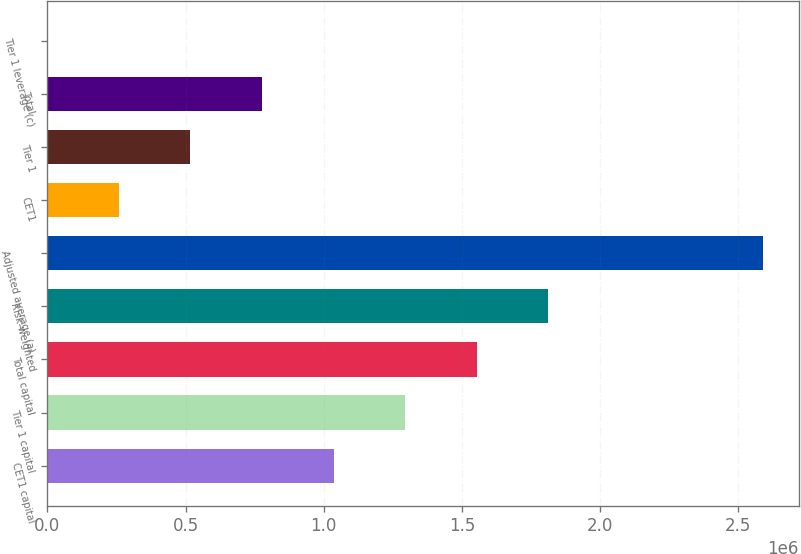Convert chart. <chart><loc_0><loc_0><loc_500><loc_500><bar_chart><fcel>CET1 capital<fcel>Tier 1 capital<fcel>Total capital<fcel>Risk-weighted<fcel>Adjusted average (a)<fcel>CET1<fcel>Tier 1<fcel>Total<fcel>Tier 1 leverage (c)<nl><fcel>1.03596e+06<fcel>1.29495e+06<fcel>1.55394e+06<fcel>1.81292e+06<fcel>2.58989e+06<fcel>258996<fcel>517984<fcel>776972<fcel>8.1<nl></chart> 